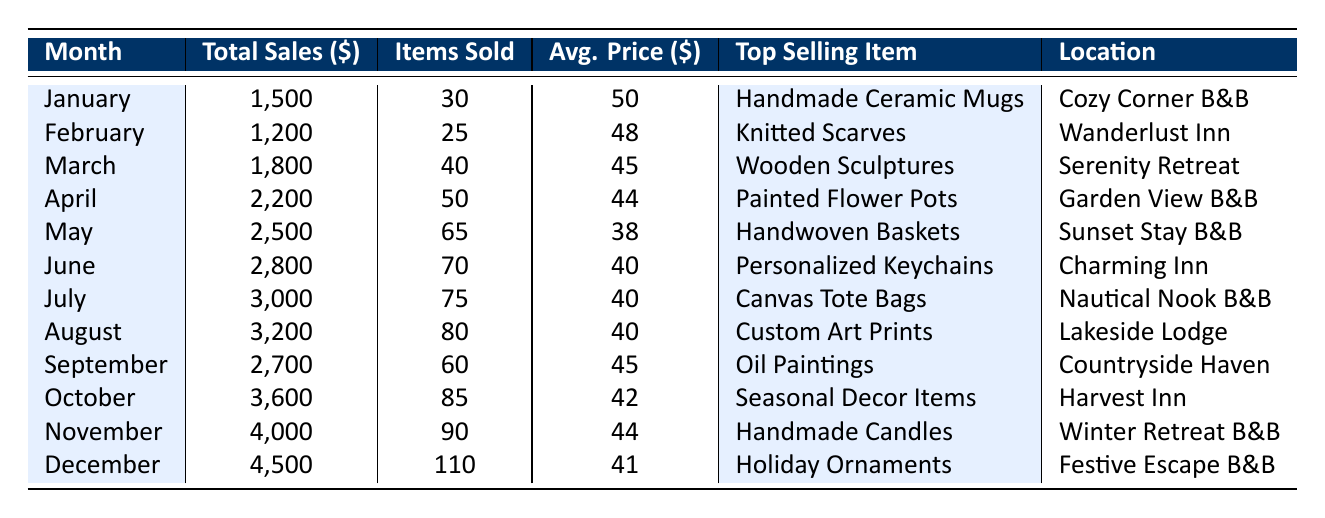What was the total sales in December? The table shows that the total sales for December is listed as 4,500.
Answer: 4,500 Which month had the highest average price per item sold? By comparing the average prices for each month, we see that January has the highest average price of 50.
Answer: January What is the total number of items sold from January to April? To find the total items sold from January to April, we add the items sold in those months: 30 (January) + 25 (February) + 40 (March) + 50 (April) = 145.
Answer: 145 Was the top-selling item in October a Handmade Candle? The table indicates that the top-selling item in October is Seasonal Decor Items, not Handmade Candles. Therefore, this statement is false.
Answer: No How much did total sales increase from June to July? To find the increase in total sales, we subtract June's total sales (2,800) from July's total sales (3,000): 3,000 - 2,800 = 200.
Answer: 200 Which month had the least number of items sold? By scanning the items sold column, February had the least number of items sold with 25.
Answer: February What was the average sales price for the top three months with the highest total sales? The top three months with the highest total sales are December (4,500), November (4,000), and October (3,600). The average sales price for these months is calculated as follows: (41 + 44 + 42) / 3 = 42.33, which is approximately 42.
Answer: 42 How many more items were sold in August compared to January? To find the difference, we take the number of items sold in August (80) and subtract the number sold in January (30): 80 - 30 = 50.
Answer: 50 In which month were the most items sold and what were they? From the table, December had the highest number of items sold, which is 110, and the top-selling item was Holiday Ornaments.
Answer: December, 110 items 